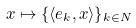<formula> <loc_0><loc_0><loc_500><loc_500>x \mapsto \{ \langle e _ { k } , x \rangle \} _ { k \in N }</formula> 